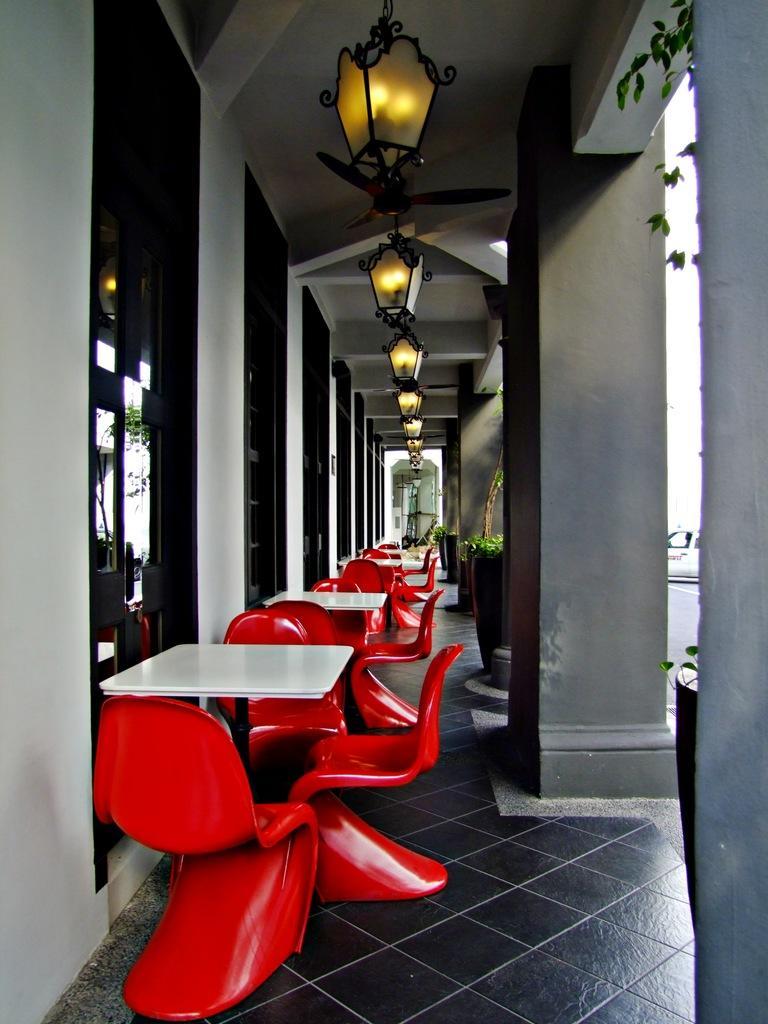In one or two sentences, can you explain what this image depicts? In this picture we can see some tables, chairs are arranged in a line, side we can see some glass windows to the wall and we can see some lights to the roof. 